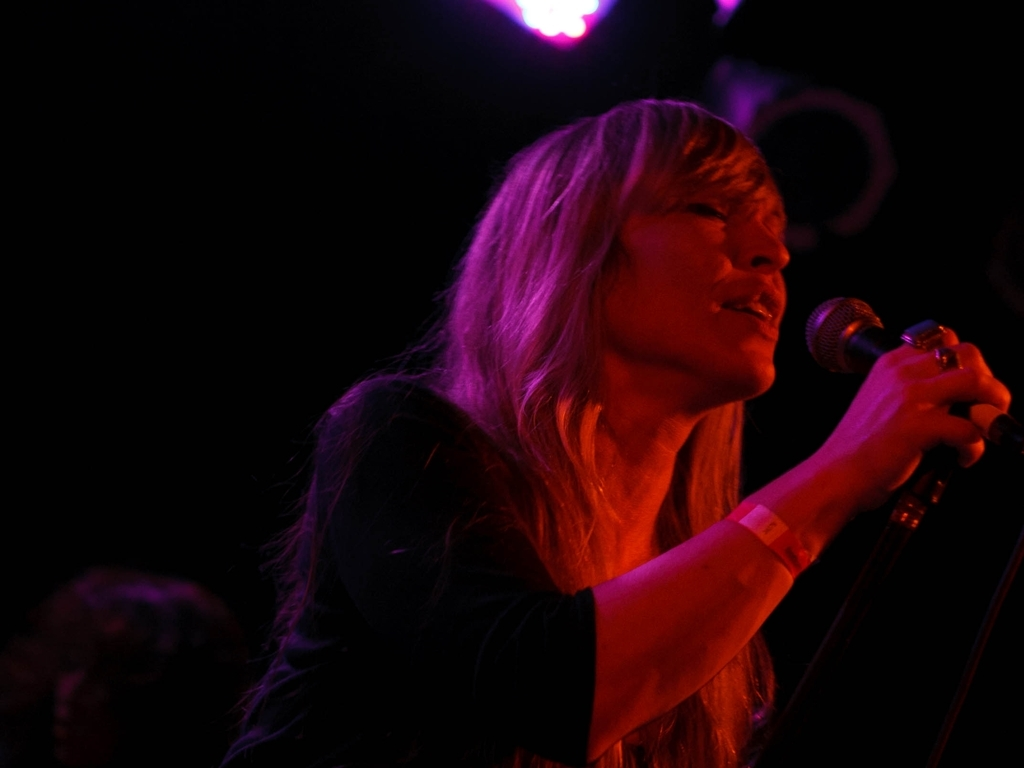How does the lighting affect the perception of the performer? The directional lighting isolates the performer from the surroundings, highlighting her facial expressions and creating a dramatic effect that emphasizes the emotional content of the song. The contrast between the shadows and the illuminated areas on her face adds a layer of depth to the visual experience for the audience. 